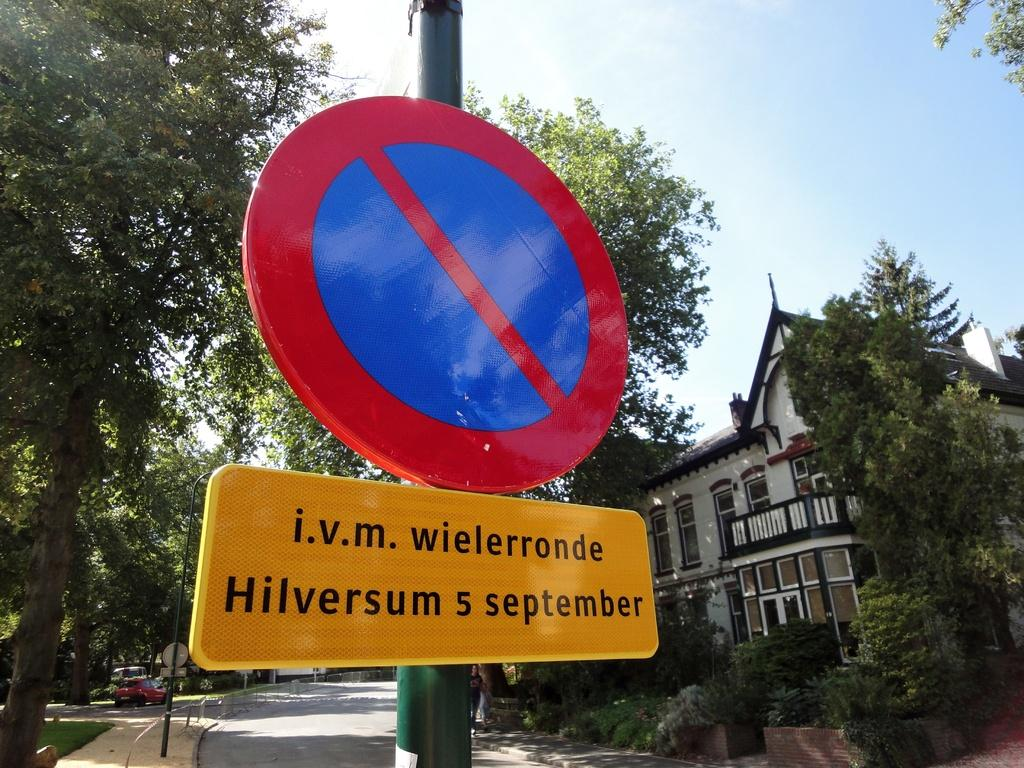<image>
Offer a succinct explanation of the picture presented. A do not enter sign with the words i.v.m wielerronde Hilversum s september 